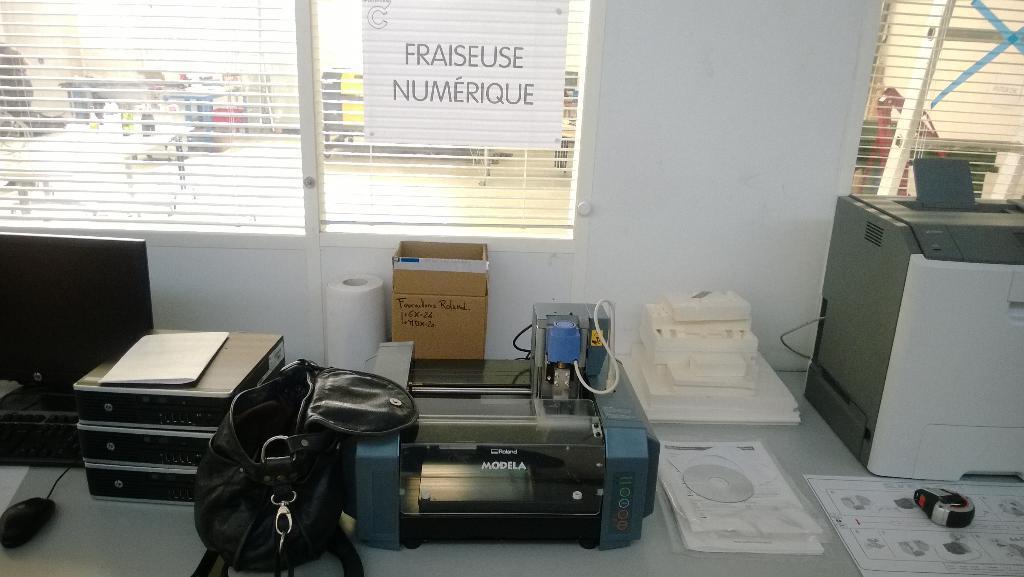Can you describe this image briefly? In this picture there is a bag. There is a box, tissue roll ,machine , mouse. At the background, there is a table and bottles. 